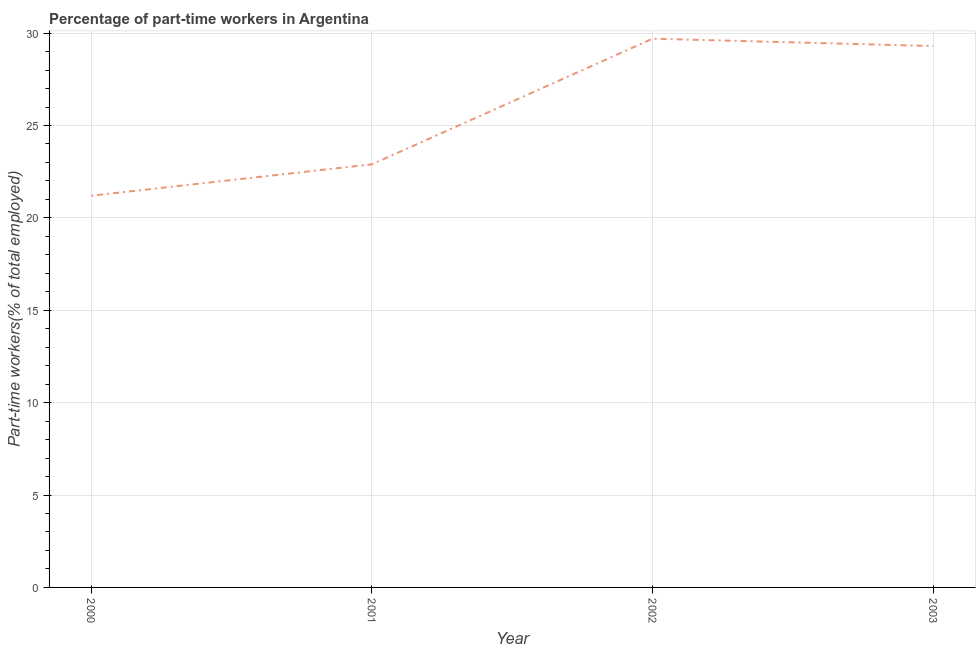What is the percentage of part-time workers in 2003?
Ensure brevity in your answer.  29.3. Across all years, what is the maximum percentage of part-time workers?
Ensure brevity in your answer.  29.7. Across all years, what is the minimum percentage of part-time workers?
Give a very brief answer. 21.2. What is the sum of the percentage of part-time workers?
Offer a terse response. 103.1. What is the difference between the percentage of part-time workers in 2000 and 2003?
Provide a succinct answer. -8.1. What is the average percentage of part-time workers per year?
Keep it short and to the point. 25.78. What is the median percentage of part-time workers?
Ensure brevity in your answer.  26.1. Do a majority of the years between 2001 and 2002 (inclusive) have percentage of part-time workers greater than 8 %?
Make the answer very short. Yes. What is the ratio of the percentage of part-time workers in 2002 to that in 2003?
Your response must be concise. 1.01. Is the difference between the percentage of part-time workers in 2001 and 2002 greater than the difference between any two years?
Your response must be concise. No. What is the difference between the highest and the second highest percentage of part-time workers?
Your response must be concise. 0.4. What is the difference between two consecutive major ticks on the Y-axis?
Offer a terse response. 5. Are the values on the major ticks of Y-axis written in scientific E-notation?
Keep it short and to the point. No. Does the graph contain any zero values?
Offer a very short reply. No. Does the graph contain grids?
Make the answer very short. Yes. What is the title of the graph?
Provide a short and direct response. Percentage of part-time workers in Argentina. What is the label or title of the Y-axis?
Provide a short and direct response. Part-time workers(% of total employed). What is the Part-time workers(% of total employed) of 2000?
Ensure brevity in your answer.  21.2. What is the Part-time workers(% of total employed) of 2001?
Your answer should be very brief. 22.9. What is the Part-time workers(% of total employed) of 2002?
Your answer should be very brief. 29.7. What is the Part-time workers(% of total employed) of 2003?
Give a very brief answer. 29.3. What is the difference between the Part-time workers(% of total employed) in 2000 and 2003?
Offer a very short reply. -8.1. What is the difference between the Part-time workers(% of total employed) in 2001 and 2002?
Your answer should be compact. -6.8. What is the difference between the Part-time workers(% of total employed) in 2002 and 2003?
Offer a very short reply. 0.4. What is the ratio of the Part-time workers(% of total employed) in 2000 to that in 2001?
Offer a terse response. 0.93. What is the ratio of the Part-time workers(% of total employed) in 2000 to that in 2002?
Your response must be concise. 0.71. What is the ratio of the Part-time workers(% of total employed) in 2000 to that in 2003?
Provide a succinct answer. 0.72. What is the ratio of the Part-time workers(% of total employed) in 2001 to that in 2002?
Your response must be concise. 0.77. What is the ratio of the Part-time workers(% of total employed) in 2001 to that in 2003?
Keep it short and to the point. 0.78. 